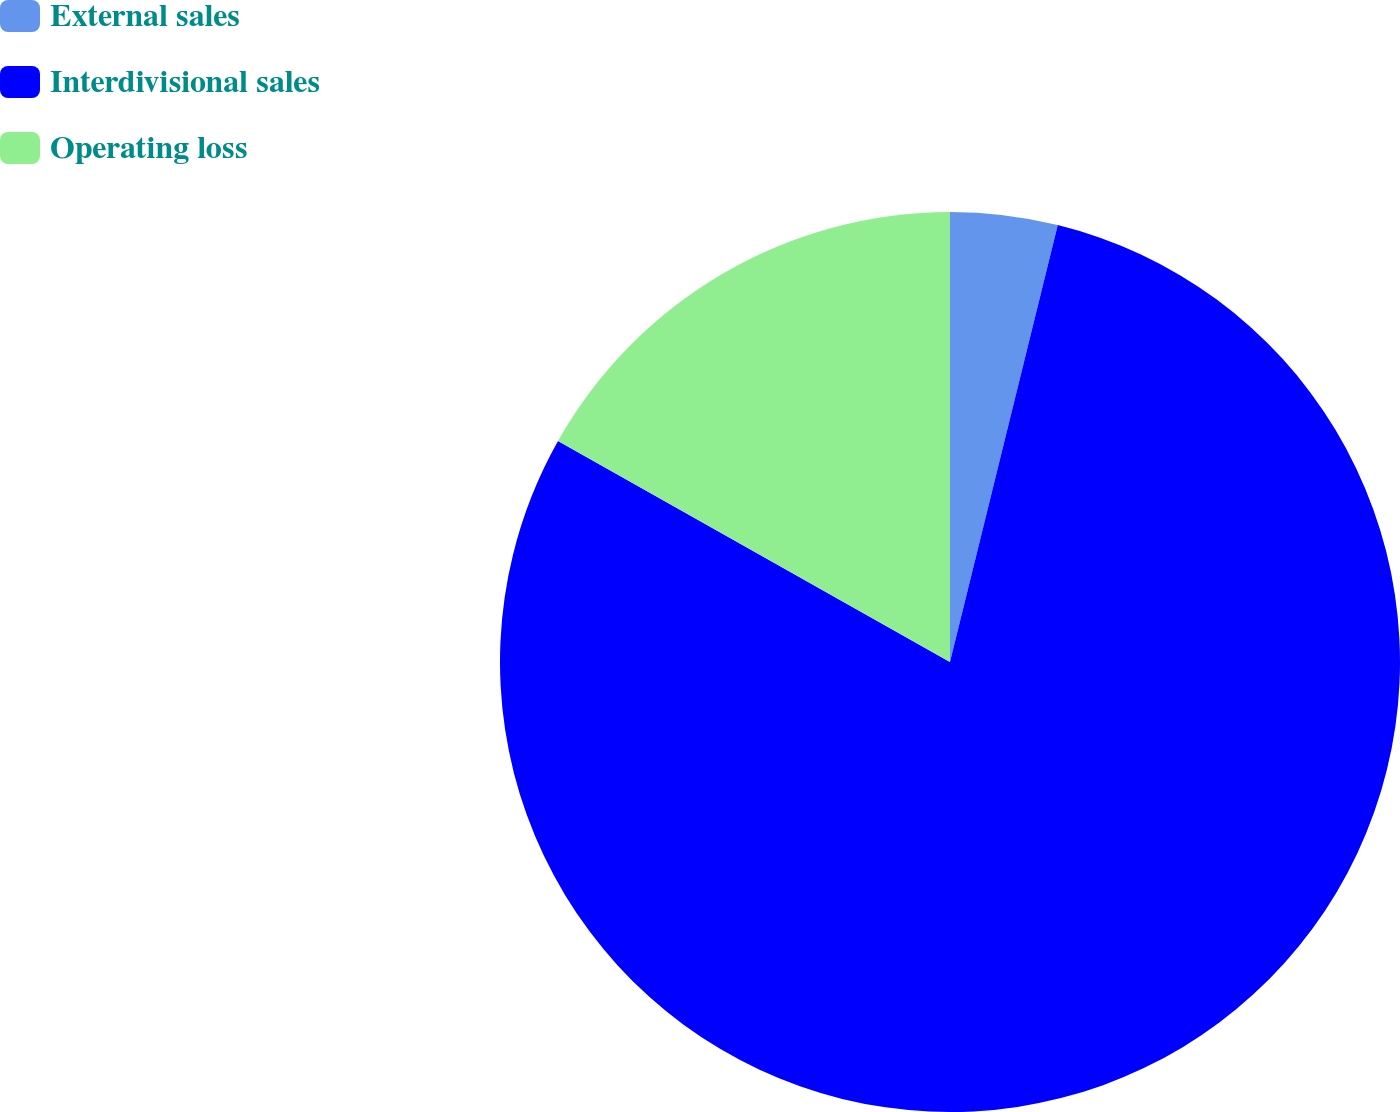Convert chart. <chart><loc_0><loc_0><loc_500><loc_500><pie_chart><fcel>External sales<fcel>Interdivisional sales<fcel>Operating loss<nl><fcel>3.85%<fcel>79.33%<fcel>16.83%<nl></chart> 